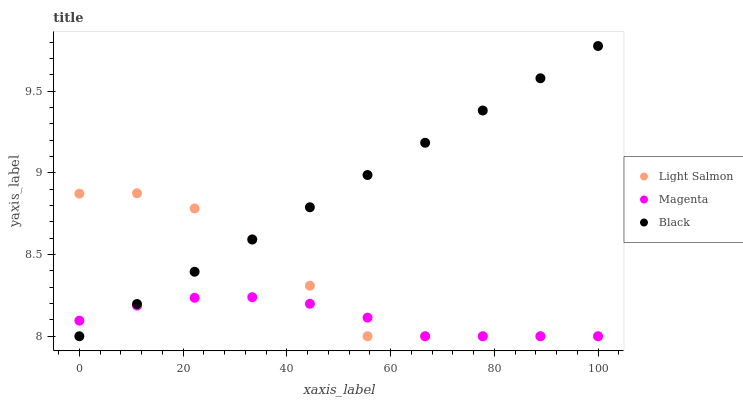Does Magenta have the minimum area under the curve?
Answer yes or no. Yes. Does Black have the maximum area under the curve?
Answer yes or no. Yes. Does Black have the minimum area under the curve?
Answer yes or no. No. Does Magenta have the maximum area under the curve?
Answer yes or no. No. Is Black the smoothest?
Answer yes or no. Yes. Is Light Salmon the roughest?
Answer yes or no. Yes. Is Magenta the smoothest?
Answer yes or no. No. Is Magenta the roughest?
Answer yes or no. No. Does Light Salmon have the lowest value?
Answer yes or no. Yes. Does Black have the highest value?
Answer yes or no. Yes. Does Magenta have the highest value?
Answer yes or no. No. Does Magenta intersect Light Salmon?
Answer yes or no. Yes. Is Magenta less than Light Salmon?
Answer yes or no. No. Is Magenta greater than Light Salmon?
Answer yes or no. No. 